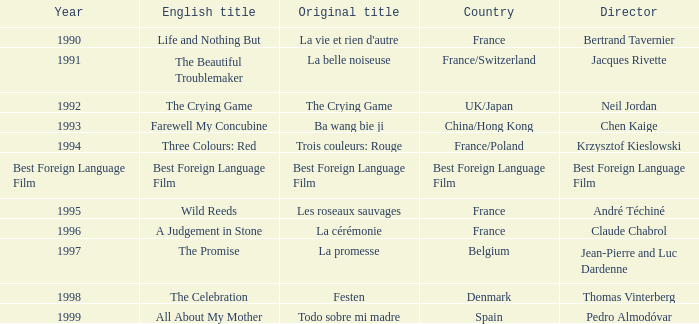Can you give me this table as a dict? {'header': ['Year', 'English title', 'Original title', 'Country', 'Director'], 'rows': [['1990', 'Life and Nothing But', "La vie et rien d'autre", 'France', 'Bertrand Tavernier'], ['1991', 'The Beautiful Troublemaker', 'La belle noiseuse', 'France/Switzerland', 'Jacques Rivette'], ['1992', 'The Crying Game', 'The Crying Game', 'UK/Japan', 'Neil Jordan'], ['1993', 'Farewell My Concubine', 'Ba wang bie ji', 'China/Hong Kong', 'Chen Kaige'], ['1994', 'Three Colours: Red', 'Trois couleurs: Rouge', 'France/Poland', 'Krzysztof Kieslowski'], ['Best Foreign Language Film', 'Best Foreign Language Film', 'Best Foreign Language Film', 'Best Foreign Language Film', 'Best Foreign Language Film'], ['1995', 'Wild Reeds', 'Les roseaux sauvages', 'France', 'André Téchiné'], ['1996', 'A Judgement in Stone', 'La cérémonie', 'France', 'Claude Chabrol'], ['1997', 'The Promise', 'La promesse', 'Belgium', 'Jean-Pierre and Luc Dardenne'], ['1998', 'The Celebration', 'Festen', 'Denmark', 'Thomas Vinterberg'], ['1999', 'All About My Mother', 'Todo sobre mi madre', 'Spain', 'Pedro Almodóvar']]} Which Country has the Director Chen Kaige? China/Hong Kong. 